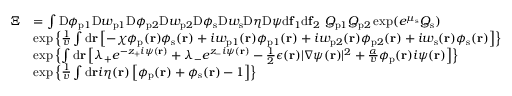Convert formula to latex. <formula><loc_0><loc_0><loc_500><loc_500>\begin{array} { r l } { \Xi } & { = \int D \phi _ { p 1 } D w _ { p 1 } D \phi _ { p 2 } D w _ { p 2 } D \phi _ { s } D w _ { s } D \eta D \psi d f _ { 1 } d f _ { 2 } \ Q _ { p 1 } Q _ { p 2 } \exp ( e ^ { \mu _ { s } } Q _ { s } ) } \\ & { \exp \left \{ \frac { 1 } { v } \int d r \left [ - \chi \phi _ { p } ( r ) \phi _ { s } ( r ) + i w _ { p 1 } ( r ) \phi _ { p 1 } ( r ) + i w _ { p 2 } ( r ) \phi _ { p 2 } ( r ) + i w _ { s } ( r ) \phi _ { s } ( r ) \right ] \right \} } \\ & { \exp \left \{ \int d r \left [ \lambda _ { + } e ^ { - z _ { + } i \psi ( r ) } + \lambda _ { - } e ^ { z _ { - } i \psi ( r ) } - \frac { 1 } { 2 } \epsilon ( r ) | \nabla \psi ( r ) | ^ { 2 } + \frac { \alpha } { v } \phi _ { p } ( r ) i \psi ( r ) \right ] \right \} } \\ & { \exp \left \{ \frac { 1 } { v } \int d r i \eta ( r ) \left [ \phi _ { p } ( r ) + \phi _ { s } ( r ) - 1 \right ] \right \} } \end{array}</formula> 